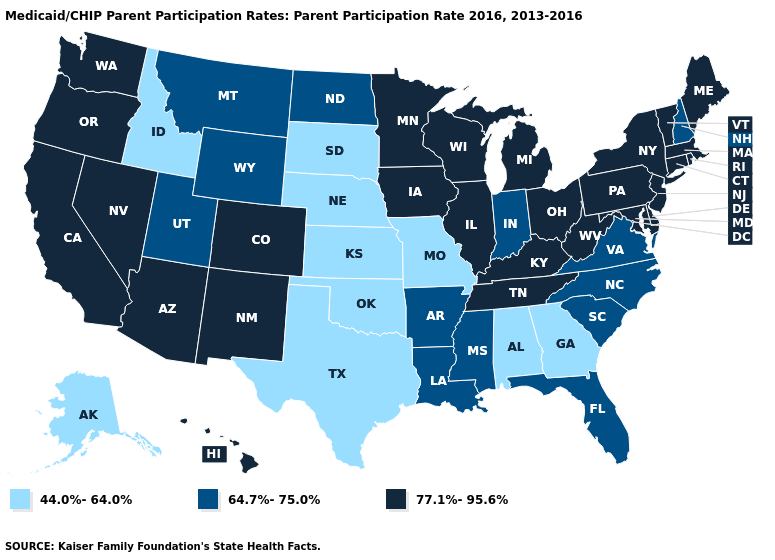What is the value of Missouri?
Quick response, please. 44.0%-64.0%. Name the states that have a value in the range 77.1%-95.6%?
Be succinct. Arizona, California, Colorado, Connecticut, Delaware, Hawaii, Illinois, Iowa, Kentucky, Maine, Maryland, Massachusetts, Michigan, Minnesota, Nevada, New Jersey, New Mexico, New York, Ohio, Oregon, Pennsylvania, Rhode Island, Tennessee, Vermont, Washington, West Virginia, Wisconsin. Which states have the highest value in the USA?
Keep it brief. Arizona, California, Colorado, Connecticut, Delaware, Hawaii, Illinois, Iowa, Kentucky, Maine, Maryland, Massachusetts, Michigan, Minnesota, Nevada, New Jersey, New Mexico, New York, Ohio, Oregon, Pennsylvania, Rhode Island, Tennessee, Vermont, Washington, West Virginia, Wisconsin. Name the states that have a value in the range 77.1%-95.6%?
Answer briefly. Arizona, California, Colorado, Connecticut, Delaware, Hawaii, Illinois, Iowa, Kentucky, Maine, Maryland, Massachusetts, Michigan, Minnesota, Nevada, New Jersey, New Mexico, New York, Ohio, Oregon, Pennsylvania, Rhode Island, Tennessee, Vermont, Washington, West Virginia, Wisconsin. What is the value of Ohio?
Keep it brief. 77.1%-95.6%. What is the value of Nebraska?
Keep it brief. 44.0%-64.0%. Does North Carolina have the highest value in the USA?
Be succinct. No. What is the value of Illinois?
Short answer required. 77.1%-95.6%. Does the map have missing data?
Give a very brief answer. No. What is the value of South Dakota?
Concise answer only. 44.0%-64.0%. Which states have the highest value in the USA?
Write a very short answer. Arizona, California, Colorado, Connecticut, Delaware, Hawaii, Illinois, Iowa, Kentucky, Maine, Maryland, Massachusetts, Michigan, Minnesota, Nevada, New Jersey, New Mexico, New York, Ohio, Oregon, Pennsylvania, Rhode Island, Tennessee, Vermont, Washington, West Virginia, Wisconsin. What is the value of Hawaii?
Short answer required. 77.1%-95.6%. Name the states that have a value in the range 44.0%-64.0%?
Quick response, please. Alabama, Alaska, Georgia, Idaho, Kansas, Missouri, Nebraska, Oklahoma, South Dakota, Texas. What is the highest value in the USA?
Give a very brief answer. 77.1%-95.6%. What is the value of California?
Quick response, please. 77.1%-95.6%. 